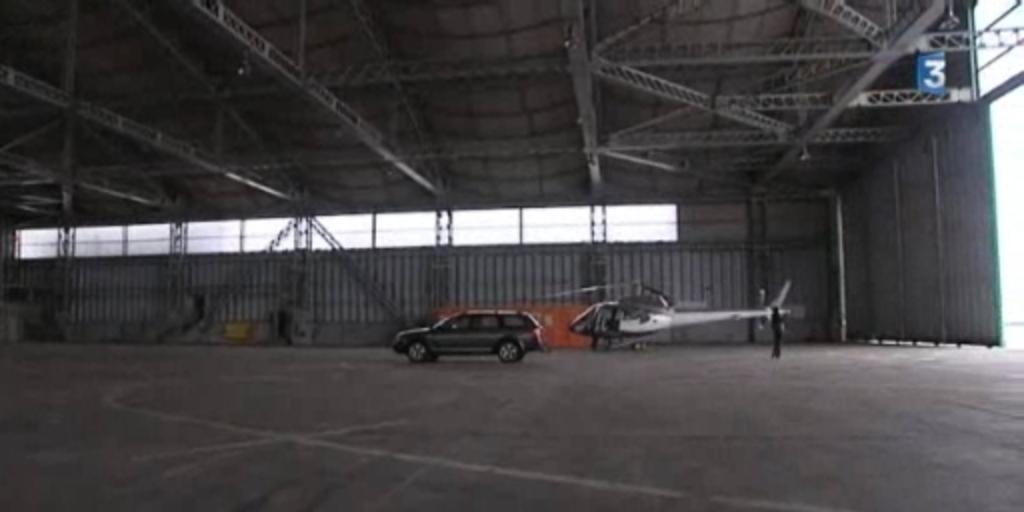<image>
Render a clear and concise summary of the photo. A warehouse with a SUV and a helicopter with the number 3 by the doors. 